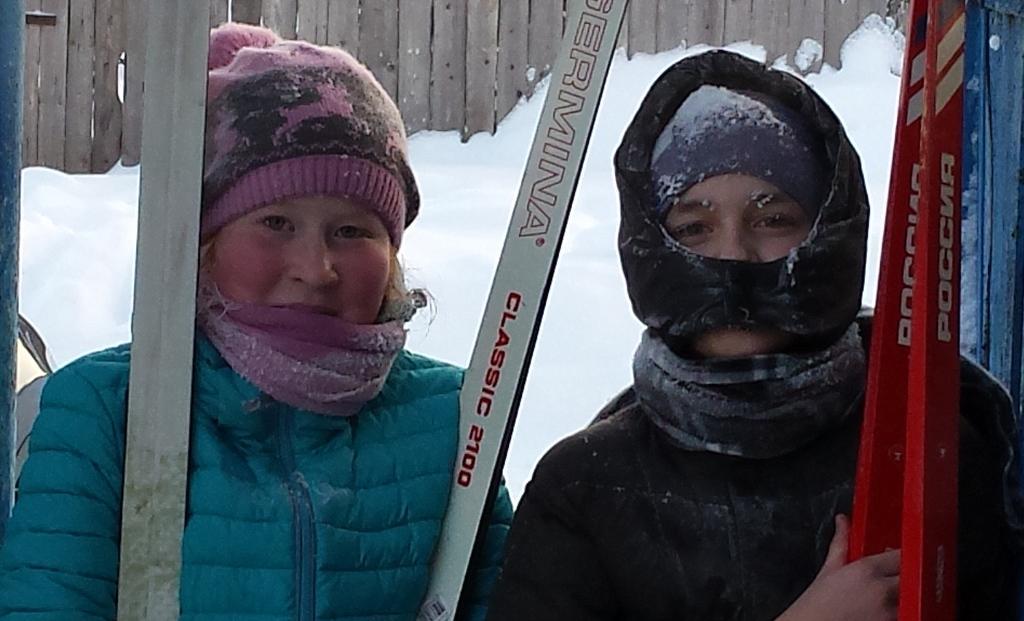In one or two sentences, can you explain what this image depicts? This 2 persons are holding a sticks. These 2 persons wore jackets. 